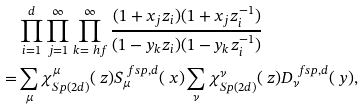<formula> <loc_0><loc_0><loc_500><loc_500>& \prod _ { i = 1 } ^ { d } \prod _ { j = 1 } ^ { \infty } \prod _ { k = \ h f } ^ { \infty } { \frac { ( 1 + x _ { j } z _ { i } ) ( 1 + x _ { j } z _ { i } ^ { - 1 } ) } { ( 1 - y _ { k } z _ { i } ) ( 1 - y _ { k } z _ { i } ^ { - 1 } ) } } \\ = & \sum _ { \mu } \chi ^ { \mu } _ { S p ( 2 d ) } ( \ z ) S _ { \mu } ^ { \ f s p , d } ( \ x ) \sum _ { \nu } \chi ^ { \nu } _ { S p ( 2 d ) } ( \ z ) D _ { \nu } ^ { \ f s p , d } ( \ y ) ,</formula> 